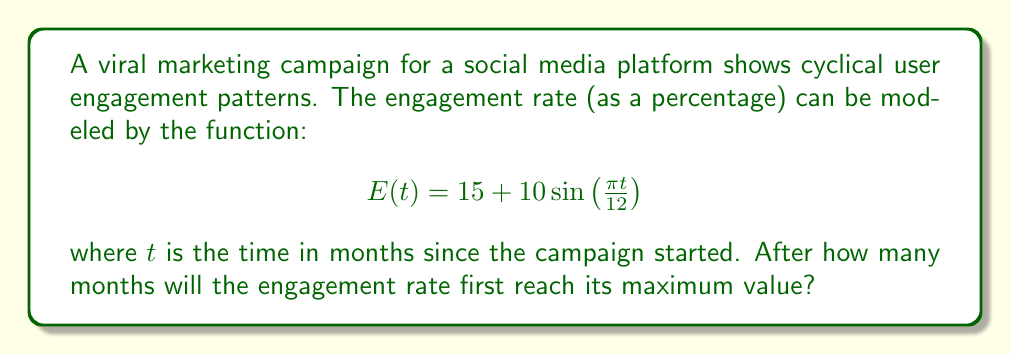Could you help me with this problem? To find when the engagement rate reaches its maximum value, we need to follow these steps:

1) The sine function reaches its maximum value of 1 when its argument is $\frac{\pi}{2}$ (or 90 degrees).

2) We need to solve the equation:

   $$\frac{\pi t}{12} = \frac{\pi}{2}$$

3) Multiply both sides by $\frac{12}{\pi}$:

   $$t = \frac{12}{2} = 6$$

4) Therefore, the maximum engagement rate occurs 6 months after the campaign starts.

5) To verify, we can calculate the engagement rate at t = 6:

   $$E(6) = 15 + 10\sin\left(\frac{\pi (6)}{12}\right) = 15 + 10\sin\left(\frac{\pi}{2}\right) = 15 + 10 = 25\%$$

This is indeed the maximum value, as the sine term contributes its maximum of 10 to the base rate of 15.
Answer: 6 months 